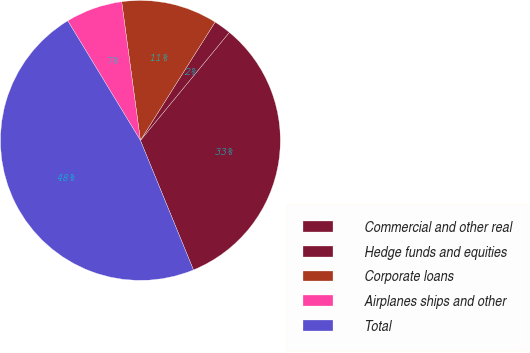Convert chart to OTSL. <chart><loc_0><loc_0><loc_500><loc_500><pie_chart><fcel>Commercial and other real<fcel>Hedge funds and equities<fcel>Corporate loans<fcel>Airplanes ships and other<fcel>Total<nl><fcel>32.85%<fcel>2.0%<fcel>11.1%<fcel>6.55%<fcel>47.5%<nl></chart> 